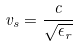<formula> <loc_0><loc_0><loc_500><loc_500>v _ { s } = \frac { c } { \sqrt { \epsilon _ { r } } }</formula> 